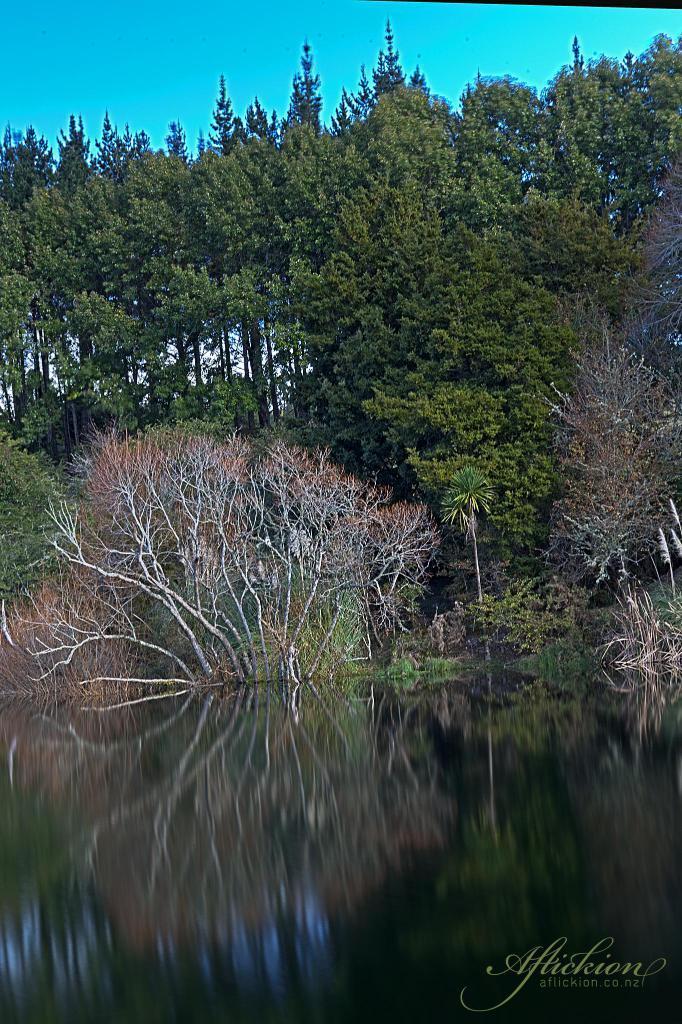Describe this image in one or two sentences. In this image there is a water surface, in the background there are trees and the sky, in the bottom right there is text. 